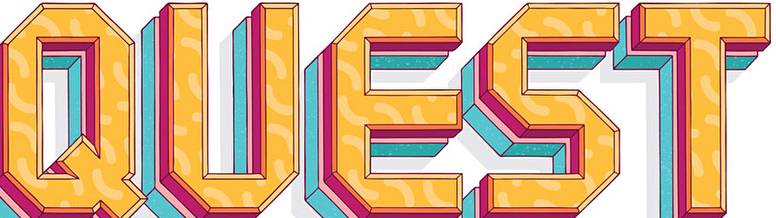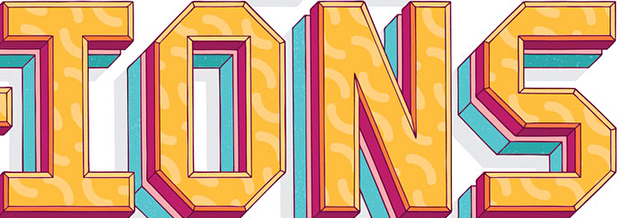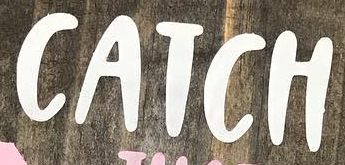What words are shown in these images in order, separated by a semicolon? QUEST; IONS; CATCH 